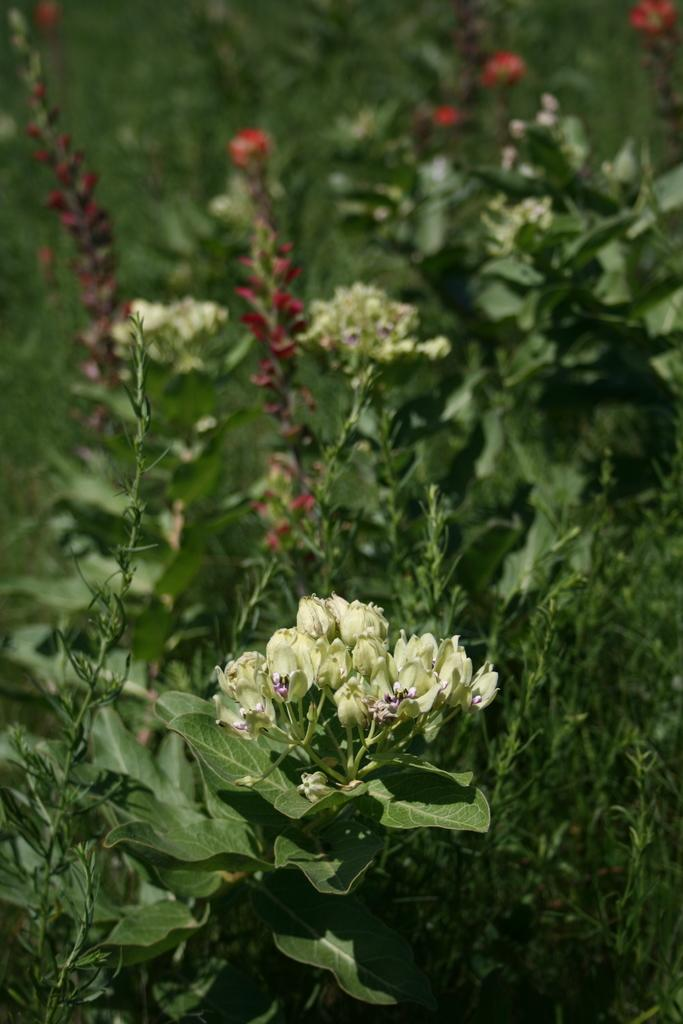What type of living organisms can be seen in the image? Plants can be seen in the image. What feature of the plants is particularly noticeable? The plants have colorful flowers. What type of sound can be heard coming from the plants in the image? There is no sound coming from the plants in the image, as plants do not produce sounds. 